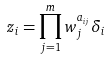Convert formula to latex. <formula><loc_0><loc_0><loc_500><loc_500>z _ { i } = \prod _ { j = 1 } ^ { m } w _ { j } ^ { a _ { i j } } \delta _ { i }</formula> 